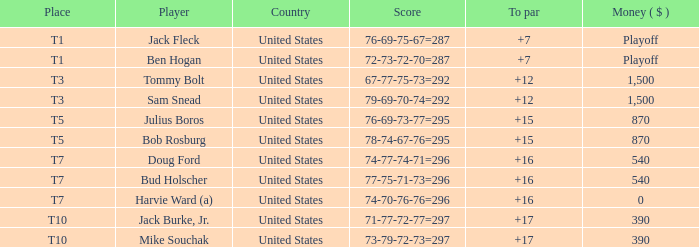What amount of money does player jack fleck have with a t1 position? Playoff. 